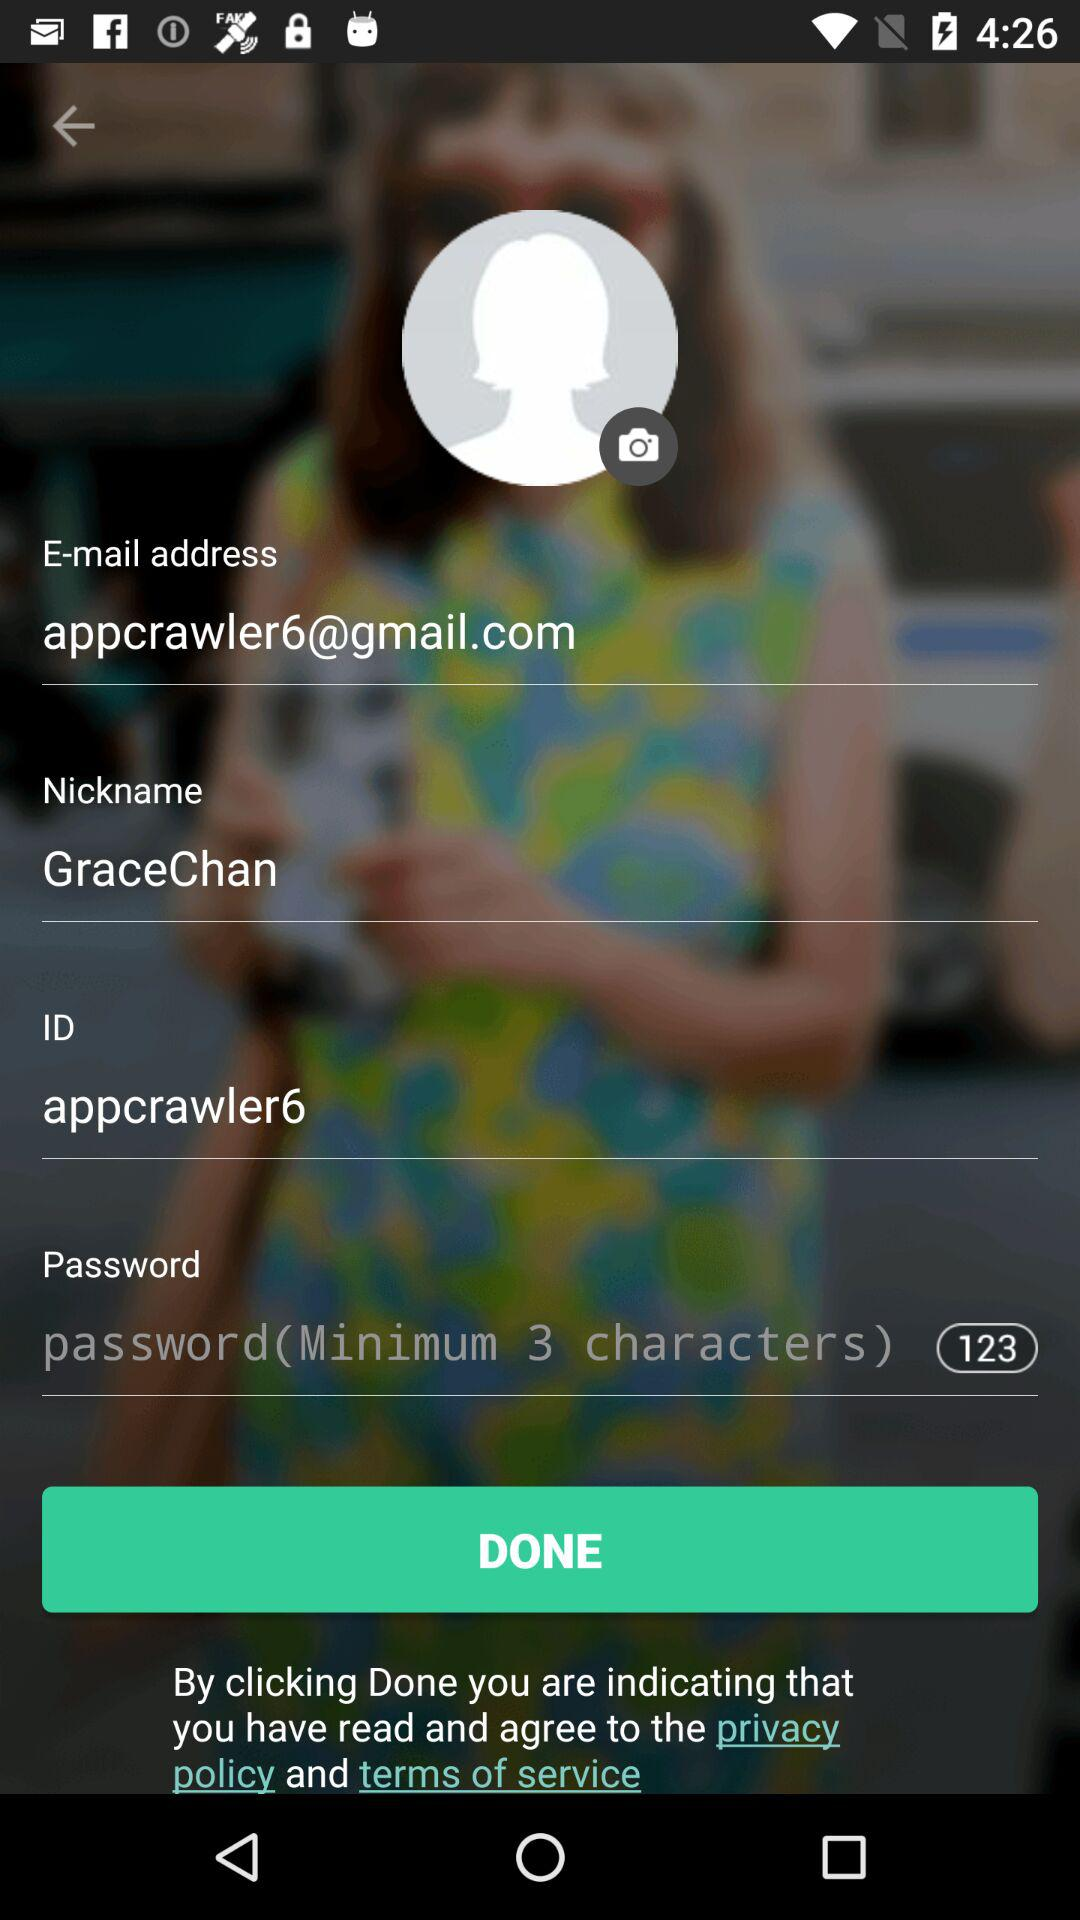How many of the input fields require you to enter information?
Answer the question using a single word or phrase. 4 